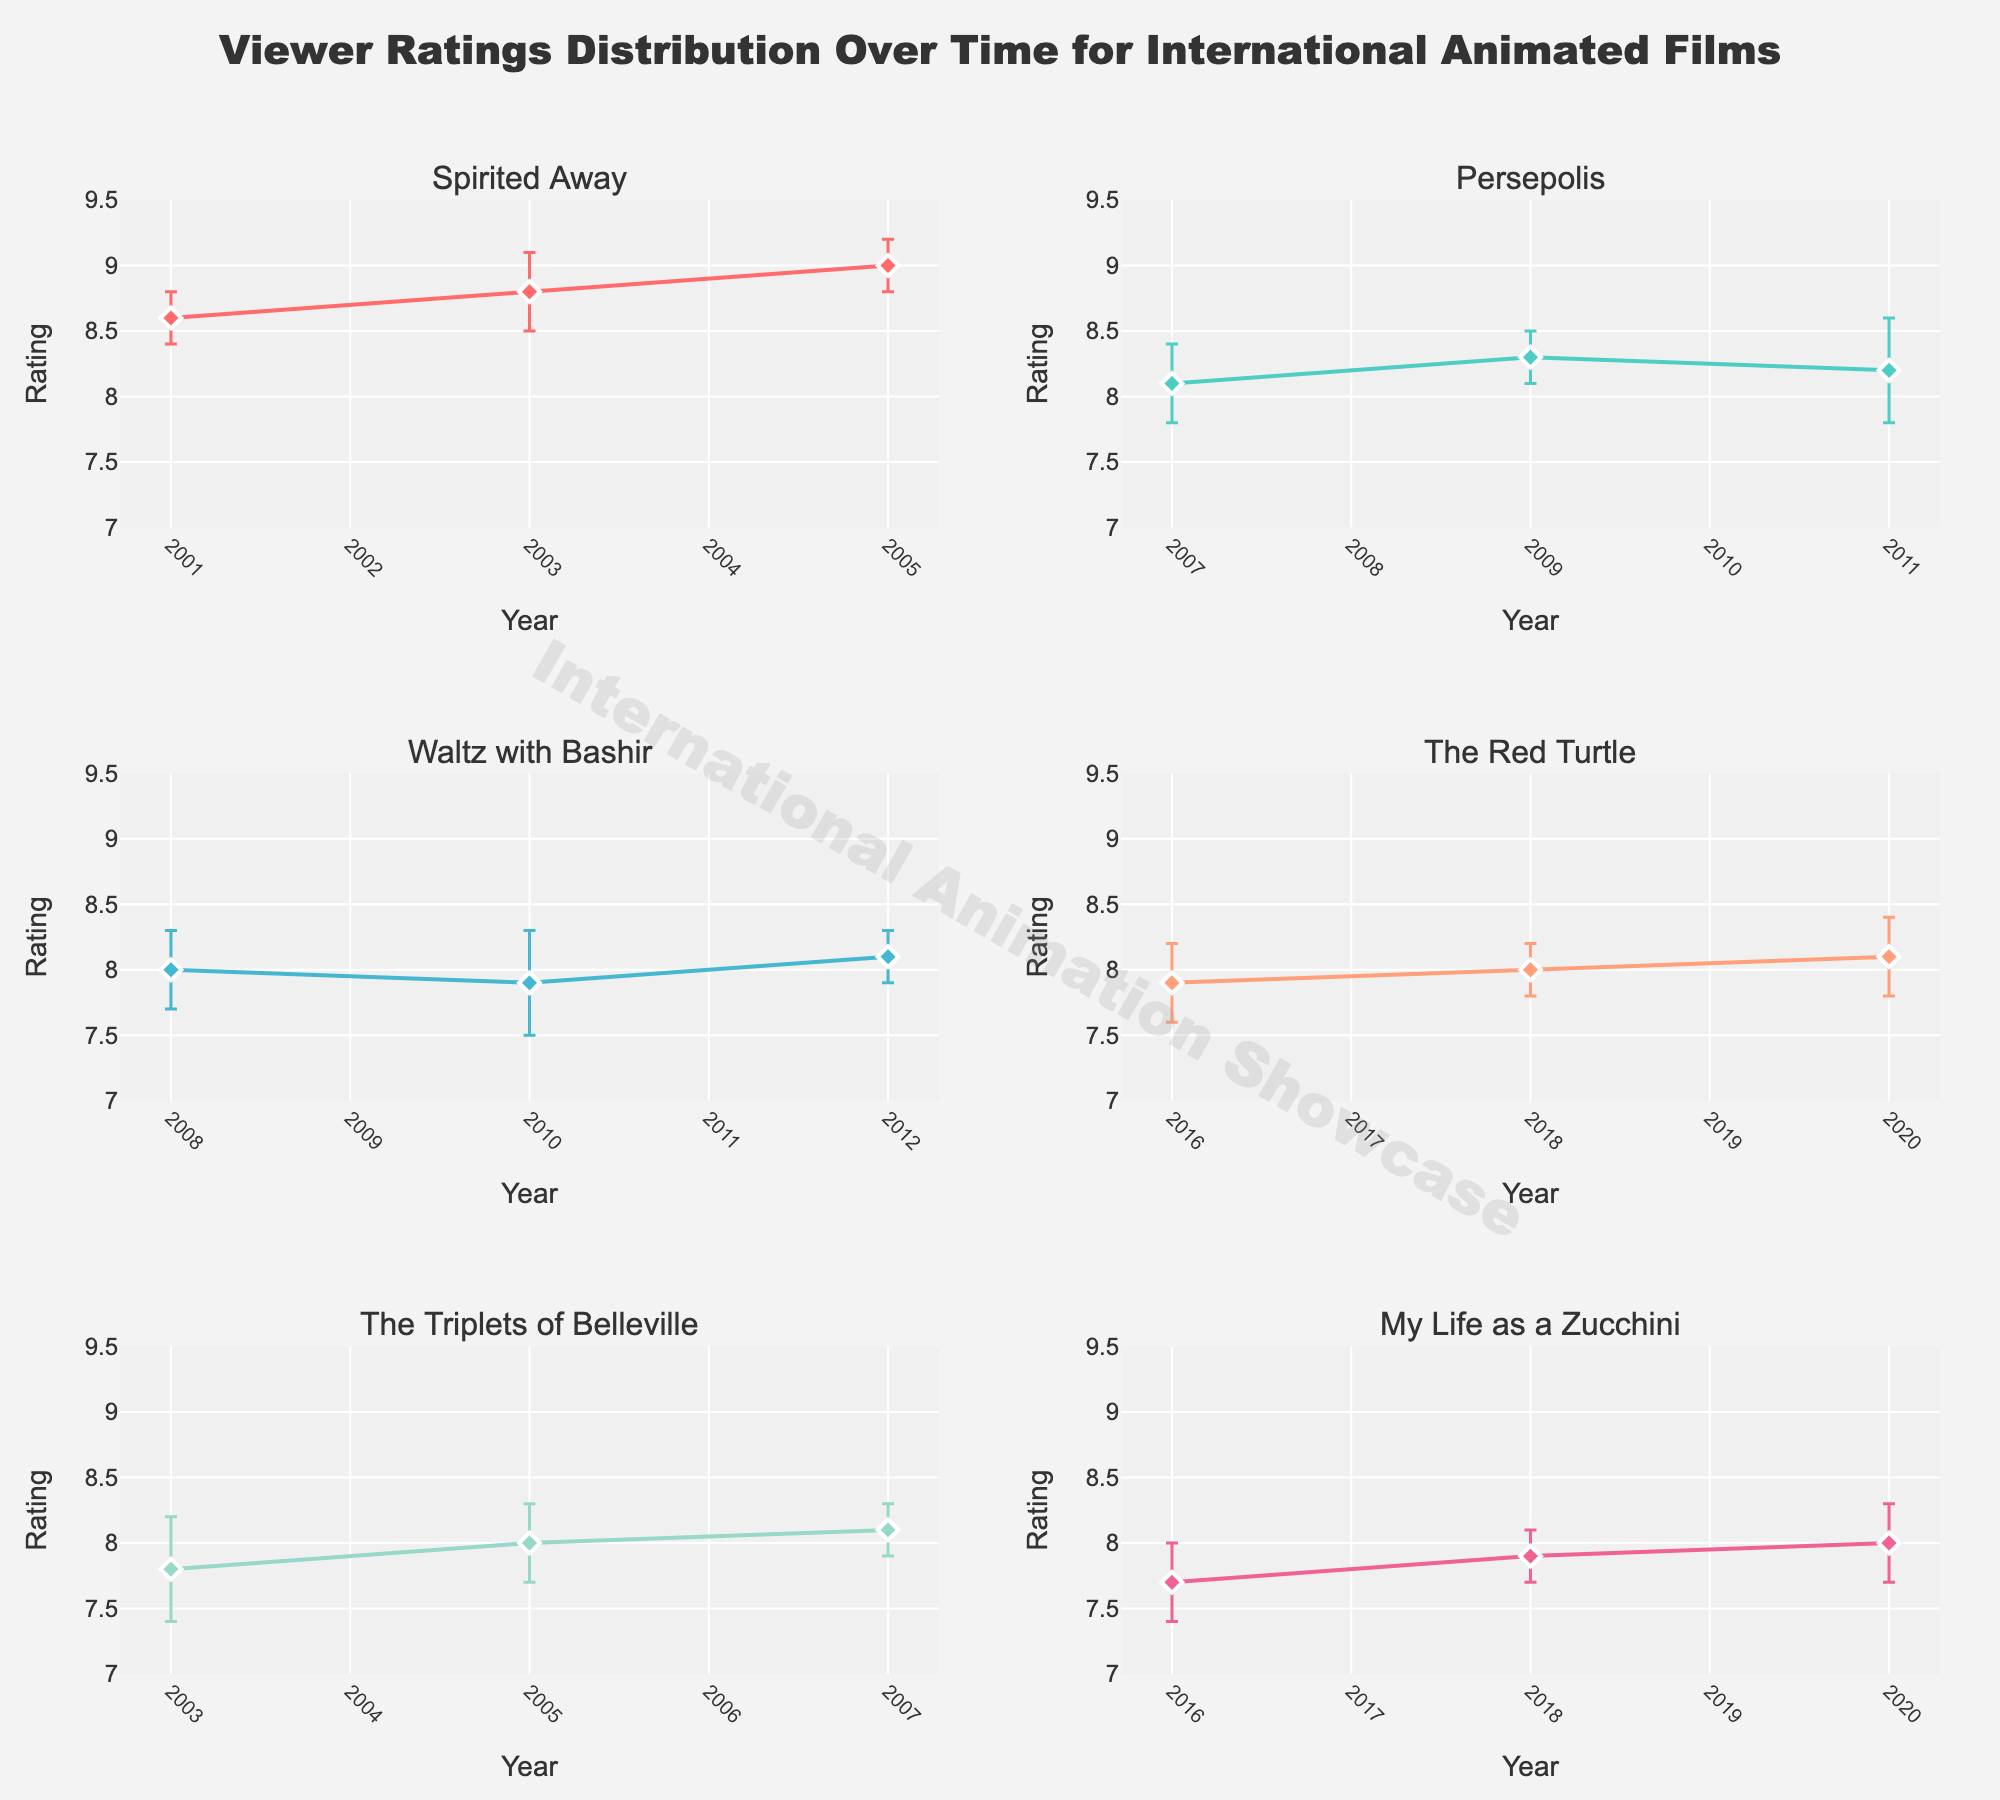What's the title of the figure? The title of the figure is displayed at the top. It reads, "Viewer Ratings Distribution Over Time for International Animated Films".
Answer: Viewer Ratings Distribution Over Time for International Animated Films Which film subplot is positioned at the top left? The subplot titles are listed at the top of each subplot; the top left subplot corresponds to "Spirited Away".
Answer: Spirited Away What is the range of the y-axis for all the subplots? Each y-axis shows a range starting from 7 to 9.5. You can see this by examining the vertical scales displayed on the left side of each subplot.
Answer: 7 to 9.5 How many data points are there for "The Red Turtle"? In the subplot for "The Red Turtle," there are three distinct points on the plot, indicating three data points.
Answer: 3 Which film shows the largest error margin in any data point? The largest error margin is visually represented by the length of the error bars. By scanning through the subplots, "The Triplets of Belleville" has the longest error bar at 0.4 in the year 2003.
Answer: The Triplets of Belleville Which year does "Waltz with Bashir" have its lowest rating, and what is that rating? In the subplot for "Waltz with Bashir," the lowest rating is in the year 2010, where the plot point is lowest, with the rating being 7.9.
Answer: 2010, 7.9 How does the trend of ratings for "My Life as a Zucchini" change over the years presented? By following the trajectory of the plot points in the subplot for "My Life as a Zucchini," the ratings are increasing over time from 7.7 in 2016 to 8.0 in 2020.
Answer: Increasing Comparing "Spirited Away" in 2001 and "The Red Turtle" in 2016, which film has a higher initial rating? "Spirited Away" in 2001 has a rating of 8.6, whereas "The Red Turtle" in 2016 has a rating of 7.9, making "Spirited Away" the film with the higher initial rating.
Answer: Spirited Away What is the highest rating achieved by any film in the figure, and which film and year does it correspond to? The highest rating can be found by looking for the highest plot point. "Spirited Away" in 2005 achieves the highest rating of 9.0.
Answer: Spirited Away, 2005 Considering "Persepolis" over the years it is displayed, what fluctuates more: its ratings or its error margins? By examining the vertical positioning of the plot points vs. the size of error bars for "Persepolis," while both fluctuate, the error margins seem larger overall, especially considering the prominent error bar of 0.4 in 2011.
Answer: Error margins 